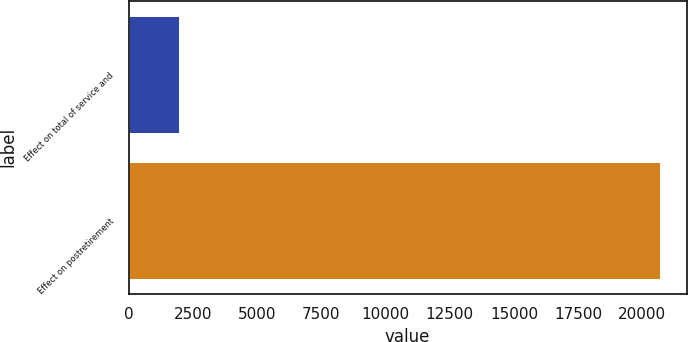Convert chart to OTSL. <chart><loc_0><loc_0><loc_500><loc_500><bar_chart><fcel>Effect on total of service and<fcel>Effect on postretirement<nl><fcel>1969<fcel>20685<nl></chart> 